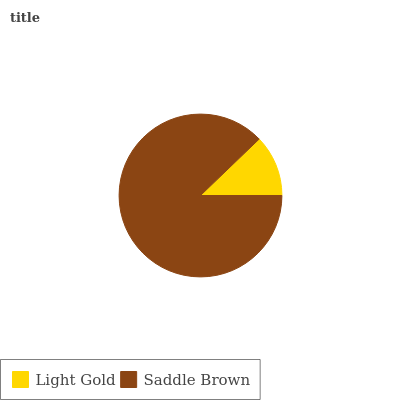Is Light Gold the minimum?
Answer yes or no. Yes. Is Saddle Brown the maximum?
Answer yes or no. Yes. Is Saddle Brown the minimum?
Answer yes or no. No. Is Saddle Brown greater than Light Gold?
Answer yes or no. Yes. Is Light Gold less than Saddle Brown?
Answer yes or no. Yes. Is Light Gold greater than Saddle Brown?
Answer yes or no. No. Is Saddle Brown less than Light Gold?
Answer yes or no. No. Is Saddle Brown the high median?
Answer yes or no. Yes. Is Light Gold the low median?
Answer yes or no. Yes. Is Light Gold the high median?
Answer yes or no. No. Is Saddle Brown the low median?
Answer yes or no. No. 